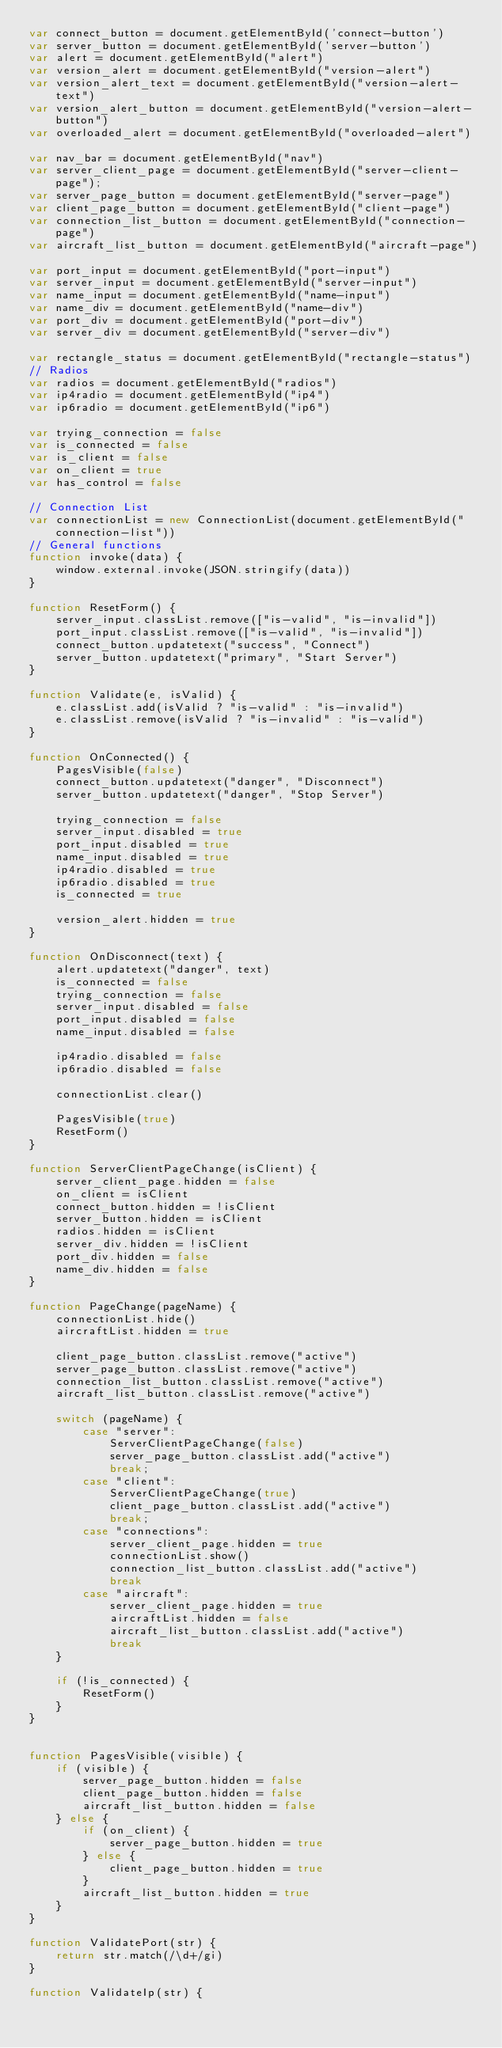Convert code to text. <code><loc_0><loc_0><loc_500><loc_500><_JavaScript_>var connect_button = document.getElementById('connect-button')
var server_button = document.getElementById('server-button')
var alert = document.getElementById("alert")
var version_alert = document.getElementById("version-alert")
var version_alert_text = document.getElementById("version-alert-text")
var version_alert_button = document.getElementById("version-alert-button")
var overloaded_alert = document.getElementById("overloaded-alert")

var nav_bar = document.getElementById("nav")
var server_client_page = document.getElementById("server-client-page");
var server_page_button = document.getElementById("server-page")
var client_page_button = document.getElementById("client-page")
var connection_list_button = document.getElementById("connection-page")
var aircraft_list_button = document.getElementById("aircraft-page")

var port_input = document.getElementById("port-input")
var server_input = document.getElementById("server-input")
var name_input = document.getElementById("name-input")
var name_div = document.getElementById("name-div")
var port_div = document.getElementById("port-div")
var server_div = document.getElementById("server-div")

var rectangle_status = document.getElementById("rectangle-status")
// Radios
var radios = document.getElementById("radios")
var ip4radio = document.getElementById("ip4")
var ip6radio = document.getElementById("ip6")

var trying_connection = false
var is_connected = false
var is_client = false
var on_client = true
var has_control = false

// Connection List
var connectionList = new ConnectionList(document.getElementById("connection-list"))
// General functions
function invoke(data) {
    window.external.invoke(JSON.stringify(data))
}

function ResetForm() {
    server_input.classList.remove(["is-valid", "is-invalid"])
    port_input.classList.remove(["is-valid", "is-invalid"])
    connect_button.updatetext("success", "Connect")
    server_button.updatetext("primary", "Start Server")
}

function Validate(e, isValid) {
    e.classList.add(isValid ? "is-valid" : "is-invalid")
    e.classList.remove(isValid ? "is-invalid" : "is-valid")
}

function OnConnected() {
    PagesVisible(false)
    connect_button.updatetext("danger", "Disconnect")
    server_button.updatetext("danger", "Stop Server")
    
    trying_connection = false
    server_input.disabled = true
    port_input.disabled = true
    name_input.disabled = true
    ip4radio.disabled = true
    ip6radio.disabled = true
    is_connected = true

    version_alert.hidden = true
}

function OnDisconnect(text) {
    alert.updatetext("danger", text)
    is_connected = false
    trying_connection = false
    server_input.disabled = false
    port_input.disabled = false
    name_input.disabled = false

    ip4radio.disabled = false
    ip6radio.disabled = false

    connectionList.clear()

    PagesVisible(true)
    ResetForm()
}

function ServerClientPageChange(isClient) {
    server_client_page.hidden = false
    on_client = isClient
    connect_button.hidden = !isClient
    server_button.hidden = isClient
    radios.hidden = isClient
    server_div.hidden = !isClient
    port_div.hidden = false
    name_div.hidden = false
}

function PageChange(pageName) {
    connectionList.hide()
    aircraftList.hidden = true

    client_page_button.classList.remove("active")
    server_page_button.classList.remove("active")
    connection_list_button.classList.remove("active")
    aircraft_list_button.classList.remove("active")

    switch (pageName) {
        case "server":
            ServerClientPageChange(false)
            server_page_button.classList.add("active")
            break;
        case "client":
            ServerClientPageChange(true)
            client_page_button.classList.add("active")
            break;
        case "connections":
            server_client_page.hidden = true
            connectionList.show()
            connection_list_button.classList.add("active")
            break
        case "aircraft":
            server_client_page.hidden = true
            aircraftList.hidden = false
            aircraft_list_button.classList.add("active")
            break
    }

    if (!is_connected) {
        ResetForm()
    }
}


function PagesVisible(visible) {
    if (visible) {
        server_page_button.hidden = false
        client_page_button.hidden = false
        aircraft_list_button.hidden = false
    } else {
        if (on_client) {
            server_page_button.hidden = true
        } else {
            client_page_button.hidden = true
        }
        aircraft_list_button.hidden = true
    }
}

function ValidatePort(str) {
    return str.match(/\d+/gi)
}

function ValidateIp(str) {</code> 